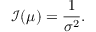Convert formula to latex. <formula><loc_0><loc_0><loc_500><loc_500>\mathcal { I } ( \mu ) = \frac { 1 } { \sigma ^ { 2 } } .</formula> 